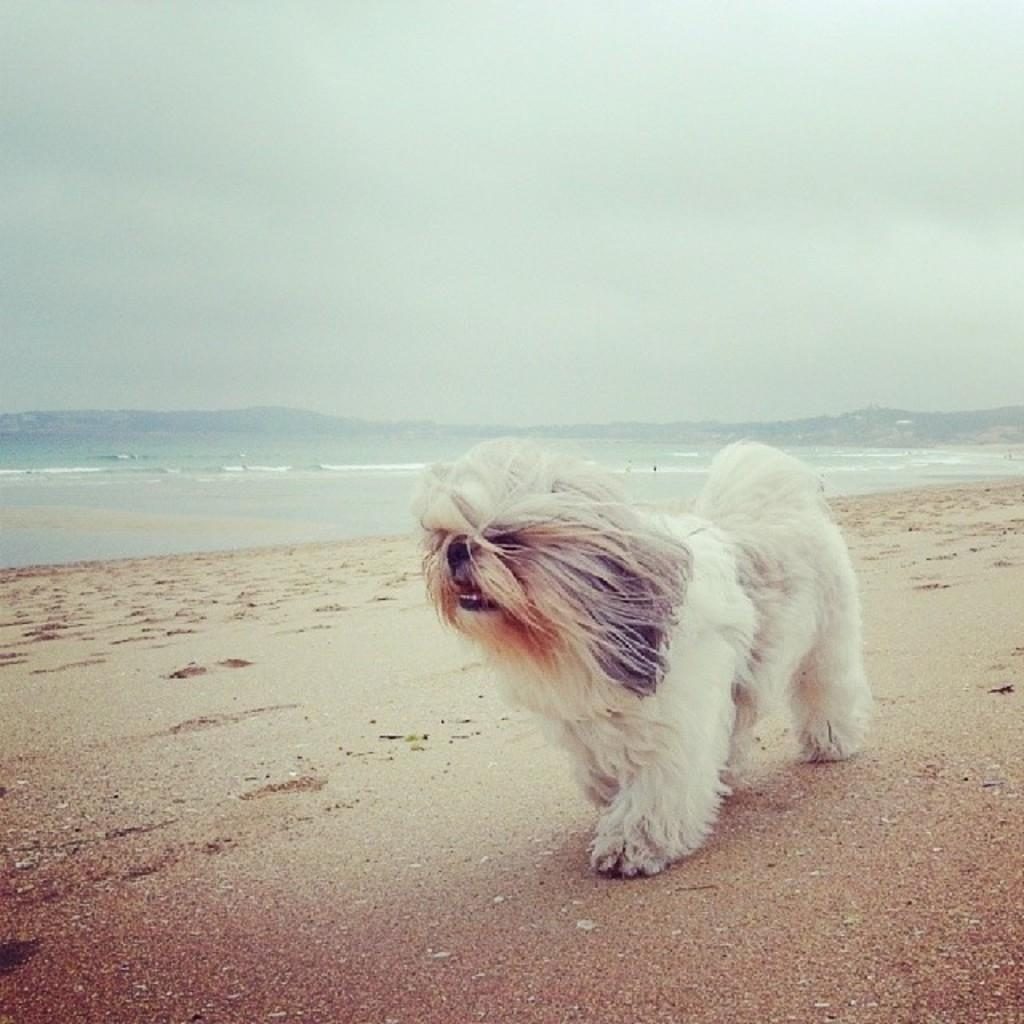What animal is present in the image? There is a dog in the image. What type of terrain is the dog on? The dog is on sand. What can be seen in the background of the image? There is water, mountains, and the sky visible in the background of the image. What type of wool is the dog wearing in the image? There is no wool present in the image, and the dog is not wearing any clothing. 